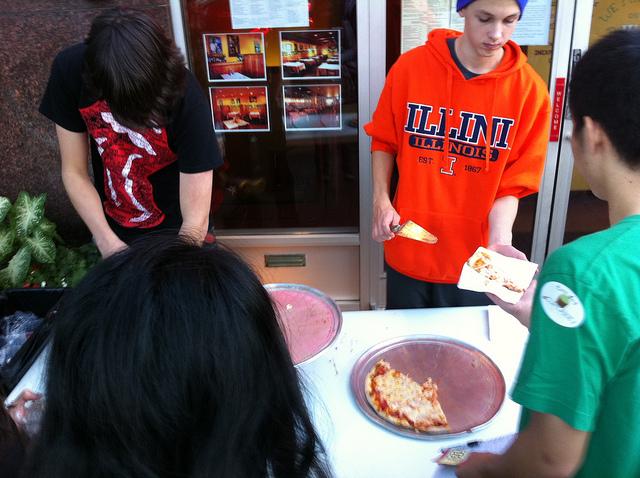What school does the red shirt depict?
Give a very brief answer. Illinois. Is this an international conference?
Answer briefly. No. Is this outdoors?
Write a very short answer. Yes. What rock band is on the black shirt?
Short answer required. Rolling stones. 